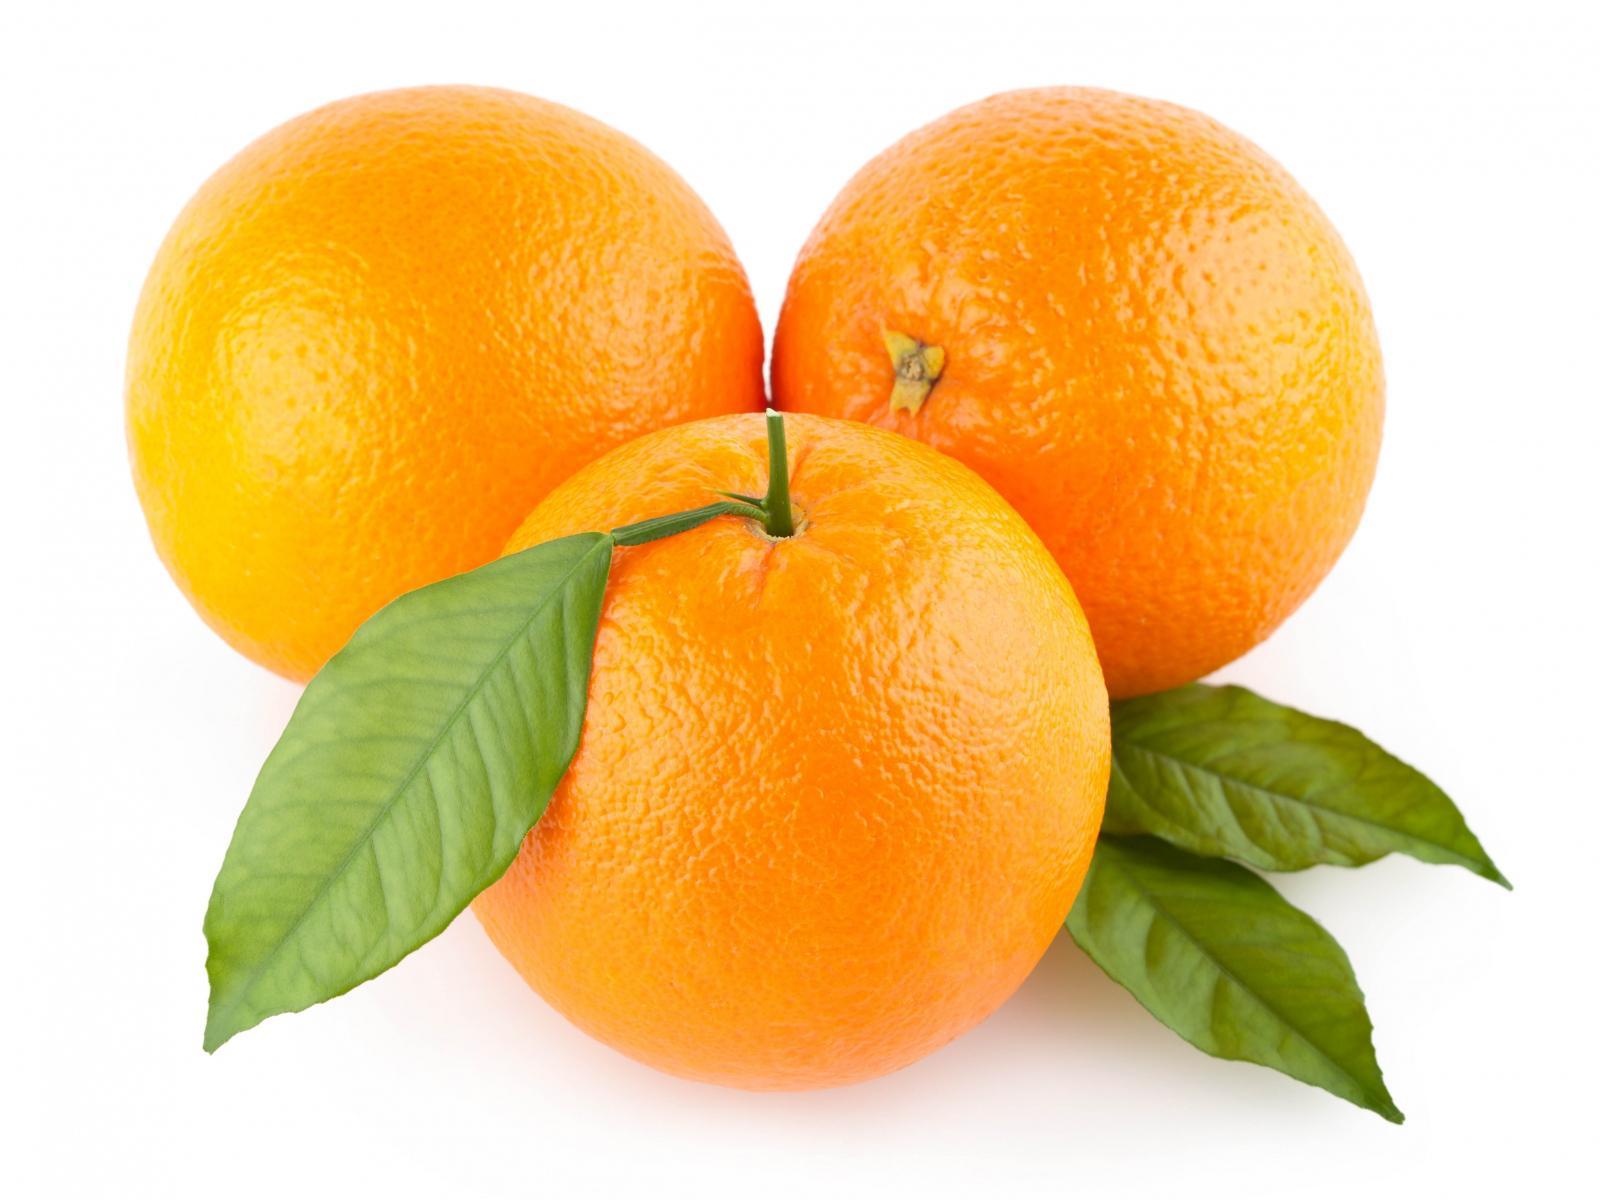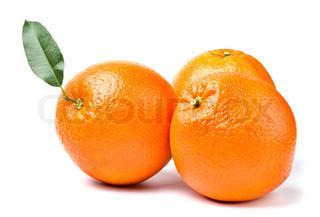The first image is the image on the left, the second image is the image on the right. For the images displayed, is the sentence "One photo has greenery and one photo has an orange that is cut, and all photos have at least three oranges." factually correct? Answer yes or no. No. The first image is the image on the left, the second image is the image on the right. Evaluate the accuracy of this statement regarding the images: "The right image includes green leaves with three whole oranges, and one image includes two cut orange parts.". Is it true? Answer yes or no. No. 